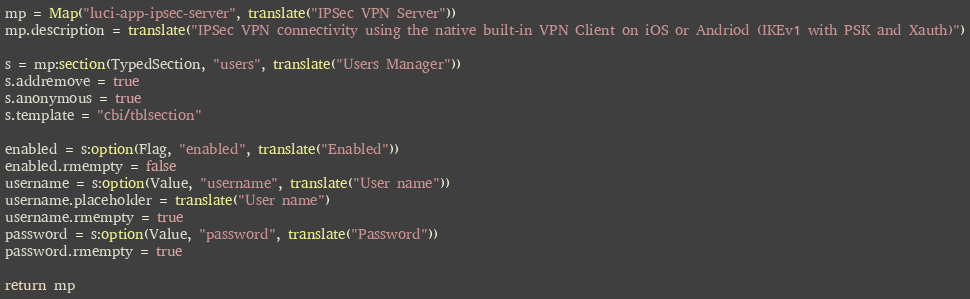<code> <loc_0><loc_0><loc_500><loc_500><_Lua_>mp = Map("luci-app-ipsec-server", translate("IPSec VPN Server"))
mp.description = translate("IPSec VPN connectivity using the native built-in VPN Client on iOS or Andriod (IKEv1 with PSK and Xauth)")

s = mp:section(TypedSection, "users", translate("Users Manager"))
s.addremove = true
s.anonymous = true
s.template = "cbi/tblsection"

enabled = s:option(Flag, "enabled", translate("Enabled"))
enabled.rmempty = false
username = s:option(Value, "username", translate("User name"))
username.placeholder = translate("User name")
username.rmempty = true
password = s:option(Value, "password", translate("Password"))
password.rmempty = true

return mp
</code> 